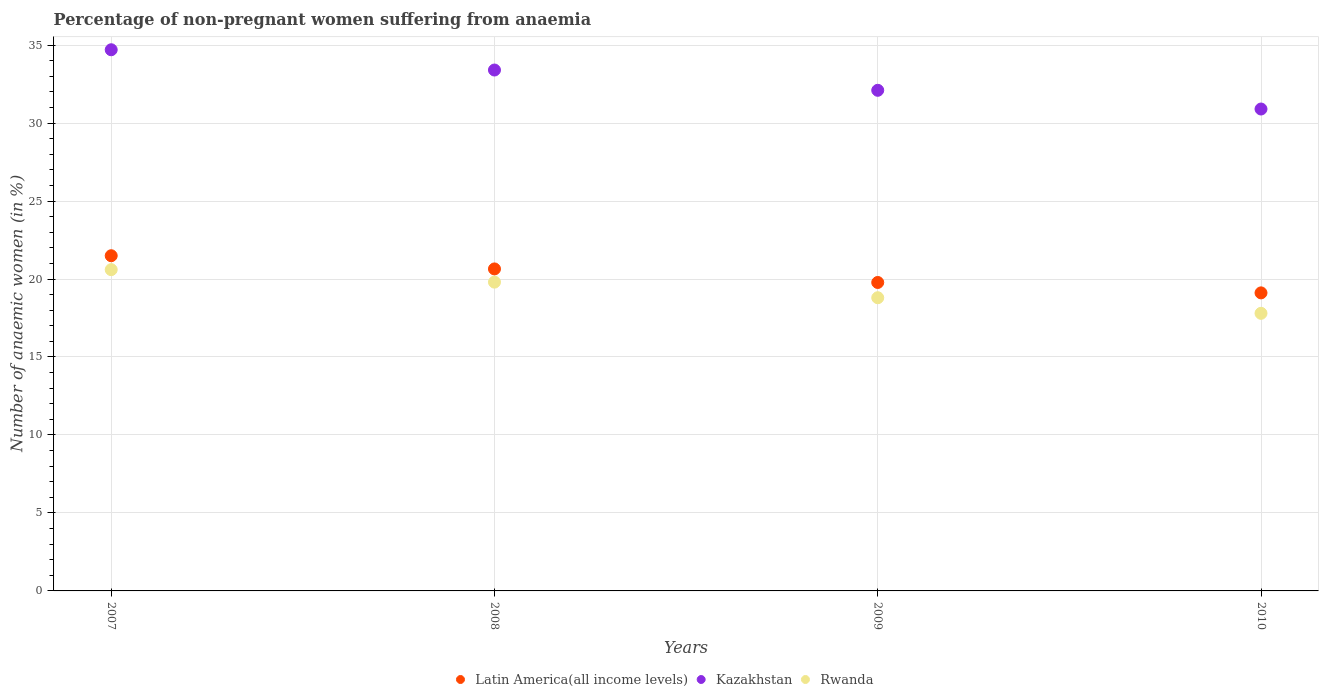Is the number of dotlines equal to the number of legend labels?
Make the answer very short. Yes. What is the percentage of non-pregnant women suffering from anaemia in Latin America(all income levels) in 2009?
Offer a terse response. 19.78. Across all years, what is the maximum percentage of non-pregnant women suffering from anaemia in Kazakhstan?
Offer a terse response. 34.7. Across all years, what is the minimum percentage of non-pregnant women suffering from anaemia in Kazakhstan?
Provide a short and direct response. 30.9. In which year was the percentage of non-pregnant women suffering from anaemia in Kazakhstan maximum?
Your response must be concise. 2007. In which year was the percentage of non-pregnant women suffering from anaemia in Latin America(all income levels) minimum?
Provide a short and direct response. 2010. What is the total percentage of non-pregnant women suffering from anaemia in Latin America(all income levels) in the graph?
Make the answer very short. 81.03. What is the difference between the percentage of non-pregnant women suffering from anaemia in Kazakhstan in 2008 and that in 2009?
Ensure brevity in your answer.  1.3. What is the difference between the percentage of non-pregnant women suffering from anaemia in Kazakhstan in 2010 and the percentage of non-pregnant women suffering from anaemia in Rwanda in 2008?
Give a very brief answer. 11.1. What is the average percentage of non-pregnant women suffering from anaemia in Kazakhstan per year?
Ensure brevity in your answer.  32.77. In the year 2008, what is the difference between the percentage of non-pregnant women suffering from anaemia in Rwanda and percentage of non-pregnant women suffering from anaemia in Latin America(all income levels)?
Provide a short and direct response. -0.85. In how many years, is the percentage of non-pregnant women suffering from anaemia in Kazakhstan greater than 32 %?
Offer a very short reply. 3. What is the ratio of the percentage of non-pregnant women suffering from anaemia in Latin America(all income levels) in 2007 to that in 2009?
Your answer should be very brief. 1.09. Is the percentage of non-pregnant women suffering from anaemia in Rwanda in 2008 less than that in 2010?
Provide a succinct answer. No. What is the difference between the highest and the second highest percentage of non-pregnant women suffering from anaemia in Kazakhstan?
Keep it short and to the point. 1.3. What is the difference between the highest and the lowest percentage of non-pregnant women suffering from anaemia in Kazakhstan?
Offer a very short reply. 3.8. Is it the case that in every year, the sum of the percentage of non-pregnant women suffering from anaemia in Kazakhstan and percentage of non-pregnant women suffering from anaemia in Rwanda  is greater than the percentage of non-pregnant women suffering from anaemia in Latin America(all income levels)?
Your answer should be compact. Yes. Is the percentage of non-pregnant women suffering from anaemia in Rwanda strictly less than the percentage of non-pregnant women suffering from anaemia in Kazakhstan over the years?
Give a very brief answer. Yes. How many years are there in the graph?
Make the answer very short. 4. Does the graph contain any zero values?
Keep it short and to the point. No. Where does the legend appear in the graph?
Make the answer very short. Bottom center. How many legend labels are there?
Offer a very short reply. 3. How are the legend labels stacked?
Give a very brief answer. Horizontal. What is the title of the graph?
Offer a terse response. Percentage of non-pregnant women suffering from anaemia. Does "Liberia" appear as one of the legend labels in the graph?
Your response must be concise. No. What is the label or title of the X-axis?
Provide a succinct answer. Years. What is the label or title of the Y-axis?
Make the answer very short. Number of anaemic women (in %). What is the Number of anaemic women (in %) of Latin America(all income levels) in 2007?
Provide a succinct answer. 21.49. What is the Number of anaemic women (in %) in Kazakhstan in 2007?
Give a very brief answer. 34.7. What is the Number of anaemic women (in %) in Rwanda in 2007?
Ensure brevity in your answer.  20.6. What is the Number of anaemic women (in %) in Latin America(all income levels) in 2008?
Offer a very short reply. 20.65. What is the Number of anaemic women (in %) in Kazakhstan in 2008?
Offer a terse response. 33.4. What is the Number of anaemic women (in %) in Rwanda in 2008?
Your answer should be compact. 19.8. What is the Number of anaemic women (in %) in Latin America(all income levels) in 2009?
Make the answer very short. 19.78. What is the Number of anaemic women (in %) in Kazakhstan in 2009?
Offer a very short reply. 32.1. What is the Number of anaemic women (in %) in Latin America(all income levels) in 2010?
Provide a succinct answer. 19.11. What is the Number of anaemic women (in %) of Kazakhstan in 2010?
Your answer should be very brief. 30.9. Across all years, what is the maximum Number of anaemic women (in %) of Latin America(all income levels)?
Ensure brevity in your answer.  21.49. Across all years, what is the maximum Number of anaemic women (in %) in Kazakhstan?
Ensure brevity in your answer.  34.7. Across all years, what is the maximum Number of anaemic women (in %) of Rwanda?
Give a very brief answer. 20.6. Across all years, what is the minimum Number of anaemic women (in %) of Latin America(all income levels)?
Keep it short and to the point. 19.11. Across all years, what is the minimum Number of anaemic women (in %) of Kazakhstan?
Give a very brief answer. 30.9. Across all years, what is the minimum Number of anaemic women (in %) of Rwanda?
Keep it short and to the point. 17.8. What is the total Number of anaemic women (in %) in Latin America(all income levels) in the graph?
Provide a succinct answer. 81.03. What is the total Number of anaemic women (in %) of Kazakhstan in the graph?
Your answer should be compact. 131.1. What is the total Number of anaemic women (in %) of Rwanda in the graph?
Give a very brief answer. 77. What is the difference between the Number of anaemic women (in %) of Latin America(all income levels) in 2007 and that in 2008?
Keep it short and to the point. 0.85. What is the difference between the Number of anaemic women (in %) in Latin America(all income levels) in 2007 and that in 2009?
Offer a very short reply. 1.71. What is the difference between the Number of anaemic women (in %) in Rwanda in 2007 and that in 2009?
Your response must be concise. 1.8. What is the difference between the Number of anaemic women (in %) in Latin America(all income levels) in 2007 and that in 2010?
Offer a terse response. 2.38. What is the difference between the Number of anaemic women (in %) of Kazakhstan in 2007 and that in 2010?
Make the answer very short. 3.8. What is the difference between the Number of anaemic women (in %) of Latin America(all income levels) in 2008 and that in 2009?
Make the answer very short. 0.87. What is the difference between the Number of anaemic women (in %) of Kazakhstan in 2008 and that in 2009?
Offer a very short reply. 1.3. What is the difference between the Number of anaemic women (in %) in Rwanda in 2008 and that in 2009?
Offer a terse response. 1. What is the difference between the Number of anaemic women (in %) in Latin America(all income levels) in 2008 and that in 2010?
Provide a short and direct response. 1.54. What is the difference between the Number of anaemic women (in %) in Latin America(all income levels) in 2009 and that in 2010?
Ensure brevity in your answer.  0.67. What is the difference between the Number of anaemic women (in %) of Rwanda in 2009 and that in 2010?
Offer a very short reply. 1. What is the difference between the Number of anaemic women (in %) in Latin America(all income levels) in 2007 and the Number of anaemic women (in %) in Kazakhstan in 2008?
Ensure brevity in your answer.  -11.91. What is the difference between the Number of anaemic women (in %) of Latin America(all income levels) in 2007 and the Number of anaemic women (in %) of Rwanda in 2008?
Give a very brief answer. 1.69. What is the difference between the Number of anaemic women (in %) of Latin America(all income levels) in 2007 and the Number of anaemic women (in %) of Kazakhstan in 2009?
Your answer should be compact. -10.61. What is the difference between the Number of anaemic women (in %) of Latin America(all income levels) in 2007 and the Number of anaemic women (in %) of Rwanda in 2009?
Offer a terse response. 2.69. What is the difference between the Number of anaemic women (in %) in Latin America(all income levels) in 2007 and the Number of anaemic women (in %) in Kazakhstan in 2010?
Make the answer very short. -9.41. What is the difference between the Number of anaemic women (in %) of Latin America(all income levels) in 2007 and the Number of anaemic women (in %) of Rwanda in 2010?
Ensure brevity in your answer.  3.69. What is the difference between the Number of anaemic women (in %) of Latin America(all income levels) in 2008 and the Number of anaemic women (in %) of Kazakhstan in 2009?
Your answer should be compact. -11.45. What is the difference between the Number of anaemic women (in %) in Latin America(all income levels) in 2008 and the Number of anaemic women (in %) in Rwanda in 2009?
Provide a succinct answer. 1.85. What is the difference between the Number of anaemic women (in %) in Kazakhstan in 2008 and the Number of anaemic women (in %) in Rwanda in 2009?
Offer a terse response. 14.6. What is the difference between the Number of anaemic women (in %) of Latin America(all income levels) in 2008 and the Number of anaemic women (in %) of Kazakhstan in 2010?
Your answer should be compact. -10.25. What is the difference between the Number of anaemic women (in %) in Latin America(all income levels) in 2008 and the Number of anaemic women (in %) in Rwanda in 2010?
Provide a succinct answer. 2.85. What is the difference between the Number of anaemic women (in %) of Kazakhstan in 2008 and the Number of anaemic women (in %) of Rwanda in 2010?
Offer a very short reply. 15.6. What is the difference between the Number of anaemic women (in %) in Latin America(all income levels) in 2009 and the Number of anaemic women (in %) in Kazakhstan in 2010?
Keep it short and to the point. -11.12. What is the difference between the Number of anaemic women (in %) of Latin America(all income levels) in 2009 and the Number of anaemic women (in %) of Rwanda in 2010?
Your response must be concise. 1.98. What is the average Number of anaemic women (in %) of Latin America(all income levels) per year?
Your response must be concise. 20.26. What is the average Number of anaemic women (in %) in Kazakhstan per year?
Keep it short and to the point. 32.77. What is the average Number of anaemic women (in %) in Rwanda per year?
Make the answer very short. 19.25. In the year 2007, what is the difference between the Number of anaemic women (in %) of Latin America(all income levels) and Number of anaemic women (in %) of Kazakhstan?
Give a very brief answer. -13.21. In the year 2007, what is the difference between the Number of anaemic women (in %) of Latin America(all income levels) and Number of anaemic women (in %) of Rwanda?
Your response must be concise. 0.89. In the year 2008, what is the difference between the Number of anaemic women (in %) of Latin America(all income levels) and Number of anaemic women (in %) of Kazakhstan?
Make the answer very short. -12.75. In the year 2008, what is the difference between the Number of anaemic women (in %) in Latin America(all income levels) and Number of anaemic women (in %) in Rwanda?
Your answer should be compact. 0.85. In the year 2009, what is the difference between the Number of anaemic women (in %) of Latin America(all income levels) and Number of anaemic women (in %) of Kazakhstan?
Provide a succinct answer. -12.32. In the year 2009, what is the difference between the Number of anaemic women (in %) in Latin America(all income levels) and Number of anaemic women (in %) in Rwanda?
Provide a short and direct response. 0.98. In the year 2010, what is the difference between the Number of anaemic women (in %) of Latin America(all income levels) and Number of anaemic women (in %) of Kazakhstan?
Keep it short and to the point. -11.79. In the year 2010, what is the difference between the Number of anaemic women (in %) of Latin America(all income levels) and Number of anaemic women (in %) of Rwanda?
Your answer should be compact. 1.31. What is the ratio of the Number of anaemic women (in %) of Latin America(all income levels) in 2007 to that in 2008?
Give a very brief answer. 1.04. What is the ratio of the Number of anaemic women (in %) of Kazakhstan in 2007 to that in 2008?
Offer a very short reply. 1.04. What is the ratio of the Number of anaemic women (in %) of Rwanda in 2007 to that in 2008?
Give a very brief answer. 1.04. What is the ratio of the Number of anaemic women (in %) in Latin America(all income levels) in 2007 to that in 2009?
Keep it short and to the point. 1.09. What is the ratio of the Number of anaemic women (in %) in Kazakhstan in 2007 to that in 2009?
Offer a terse response. 1.08. What is the ratio of the Number of anaemic women (in %) in Rwanda in 2007 to that in 2009?
Offer a terse response. 1.1. What is the ratio of the Number of anaemic women (in %) of Latin America(all income levels) in 2007 to that in 2010?
Keep it short and to the point. 1.12. What is the ratio of the Number of anaemic women (in %) of Kazakhstan in 2007 to that in 2010?
Your answer should be very brief. 1.12. What is the ratio of the Number of anaemic women (in %) in Rwanda in 2007 to that in 2010?
Provide a succinct answer. 1.16. What is the ratio of the Number of anaemic women (in %) in Latin America(all income levels) in 2008 to that in 2009?
Your answer should be compact. 1.04. What is the ratio of the Number of anaemic women (in %) of Kazakhstan in 2008 to that in 2009?
Your answer should be very brief. 1.04. What is the ratio of the Number of anaemic women (in %) of Rwanda in 2008 to that in 2009?
Keep it short and to the point. 1.05. What is the ratio of the Number of anaemic women (in %) of Latin America(all income levels) in 2008 to that in 2010?
Ensure brevity in your answer.  1.08. What is the ratio of the Number of anaemic women (in %) in Kazakhstan in 2008 to that in 2010?
Your answer should be very brief. 1.08. What is the ratio of the Number of anaemic women (in %) in Rwanda in 2008 to that in 2010?
Give a very brief answer. 1.11. What is the ratio of the Number of anaemic women (in %) in Latin America(all income levels) in 2009 to that in 2010?
Offer a very short reply. 1.03. What is the ratio of the Number of anaemic women (in %) of Kazakhstan in 2009 to that in 2010?
Provide a short and direct response. 1.04. What is the ratio of the Number of anaemic women (in %) of Rwanda in 2009 to that in 2010?
Your response must be concise. 1.06. What is the difference between the highest and the second highest Number of anaemic women (in %) in Latin America(all income levels)?
Give a very brief answer. 0.85. What is the difference between the highest and the second highest Number of anaemic women (in %) of Rwanda?
Your answer should be compact. 0.8. What is the difference between the highest and the lowest Number of anaemic women (in %) of Latin America(all income levels)?
Make the answer very short. 2.38. 